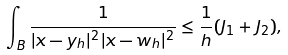<formula> <loc_0><loc_0><loc_500><loc_500>\int _ { B } \frac { 1 } { | x - y _ { h } | ^ { 2 } | x - w _ { h } | ^ { 2 } } \leq \frac { 1 } { h } ( J _ { 1 } + J _ { 2 } ) ,</formula> 